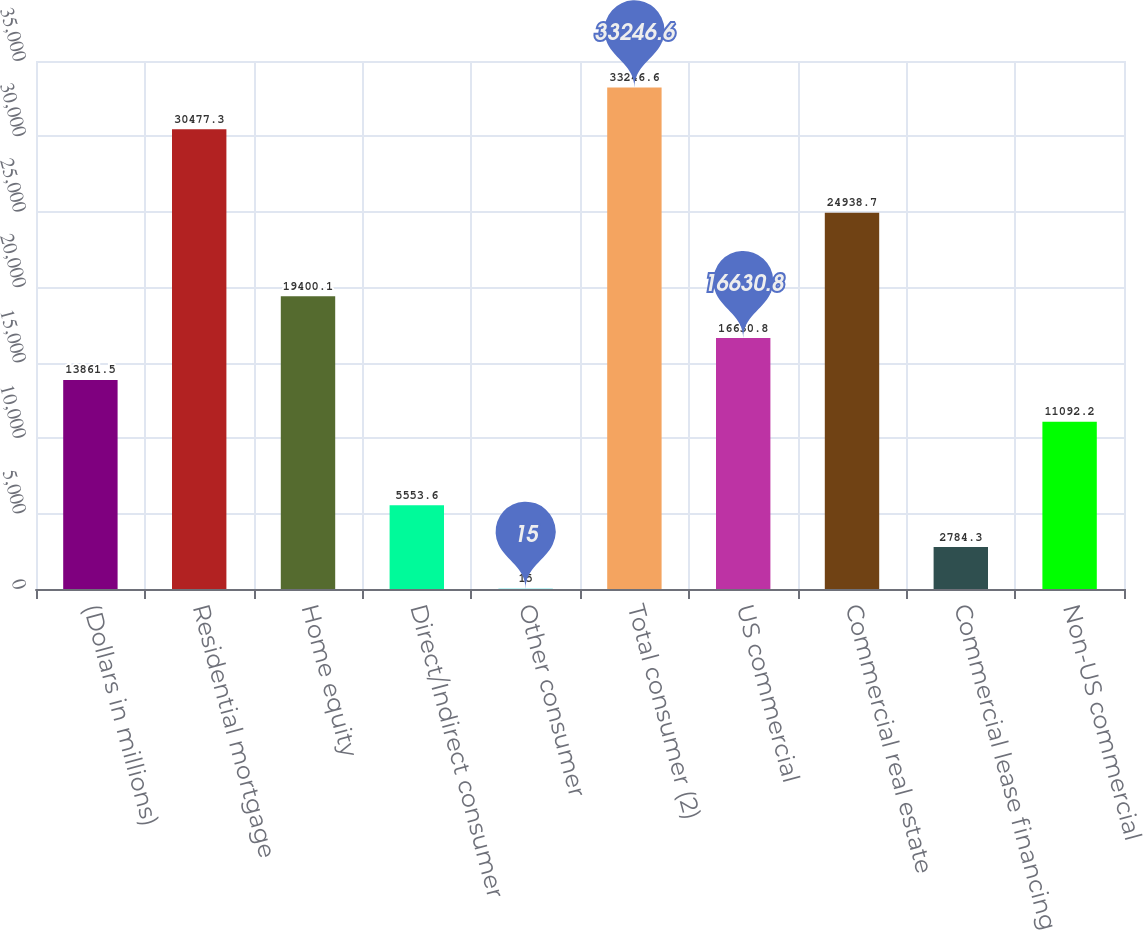<chart> <loc_0><loc_0><loc_500><loc_500><bar_chart><fcel>(Dollars in millions)<fcel>Residential mortgage<fcel>Home equity<fcel>Direct/Indirect consumer<fcel>Other consumer<fcel>Total consumer (2)<fcel>US commercial<fcel>Commercial real estate<fcel>Commercial lease financing<fcel>Non-US commercial<nl><fcel>13861.5<fcel>30477.3<fcel>19400.1<fcel>5553.6<fcel>15<fcel>33246.6<fcel>16630.8<fcel>24938.7<fcel>2784.3<fcel>11092.2<nl></chart> 